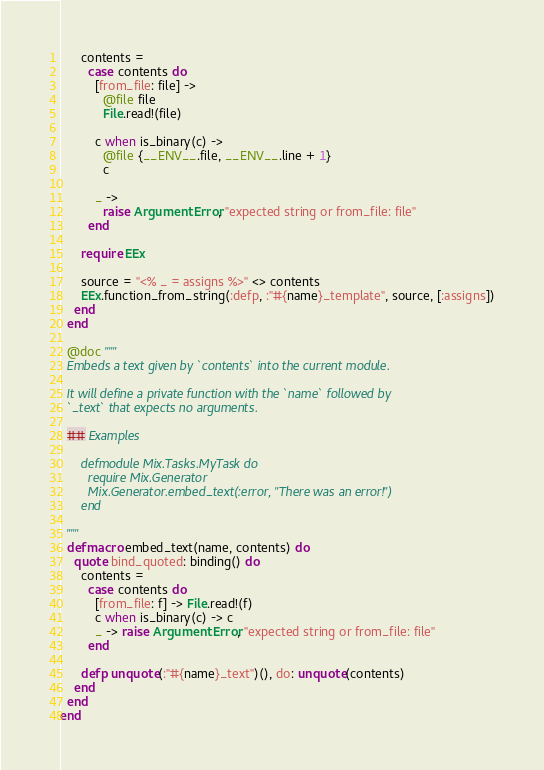Convert code to text. <code><loc_0><loc_0><loc_500><loc_500><_Elixir_>      contents =
        case contents do
          [from_file: file] ->
            @file file
            File.read!(file)

          c when is_binary(c) ->
            @file {__ENV__.file, __ENV__.line + 1}
            c

          _ ->
            raise ArgumentError, "expected string or from_file: file"
        end

      require EEx

      source = "<% _ = assigns %>" <> contents
      EEx.function_from_string(:defp, :"#{name}_template", source, [:assigns])
    end
  end

  @doc """
  Embeds a text given by `contents` into the current module.

  It will define a private function with the `name` followed by
  `_text` that expects no arguments.

  ## Examples

      defmodule Mix.Tasks.MyTask do
        require Mix.Generator
        Mix.Generator.embed_text(:error, "There was an error!")
      end

  """
  defmacro embed_text(name, contents) do
    quote bind_quoted: binding() do
      contents =
        case contents do
          [from_file: f] -> File.read!(f)
          c when is_binary(c) -> c
          _ -> raise ArgumentError, "expected string or from_file: file"
        end

      defp unquote(:"#{name}_text")(), do: unquote(contents)
    end
  end
end
</code> 